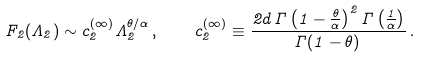<formula> <loc_0><loc_0><loc_500><loc_500>F _ { 2 } ( \Lambda _ { 2 } ) \sim c _ { 2 } ^ { ( \infty ) } \Lambda _ { 2 } ^ { \theta / \alpha } \, , \quad c _ { 2 } ^ { ( \infty ) } \equiv \frac { 2 d \, \Gamma \left ( 1 - \frac { \theta } { \alpha } \right ) ^ { 2 } \Gamma \left ( \frac { 1 } { \alpha } \right ) } { \Gamma ( 1 - \theta ) \, } \, .</formula> 